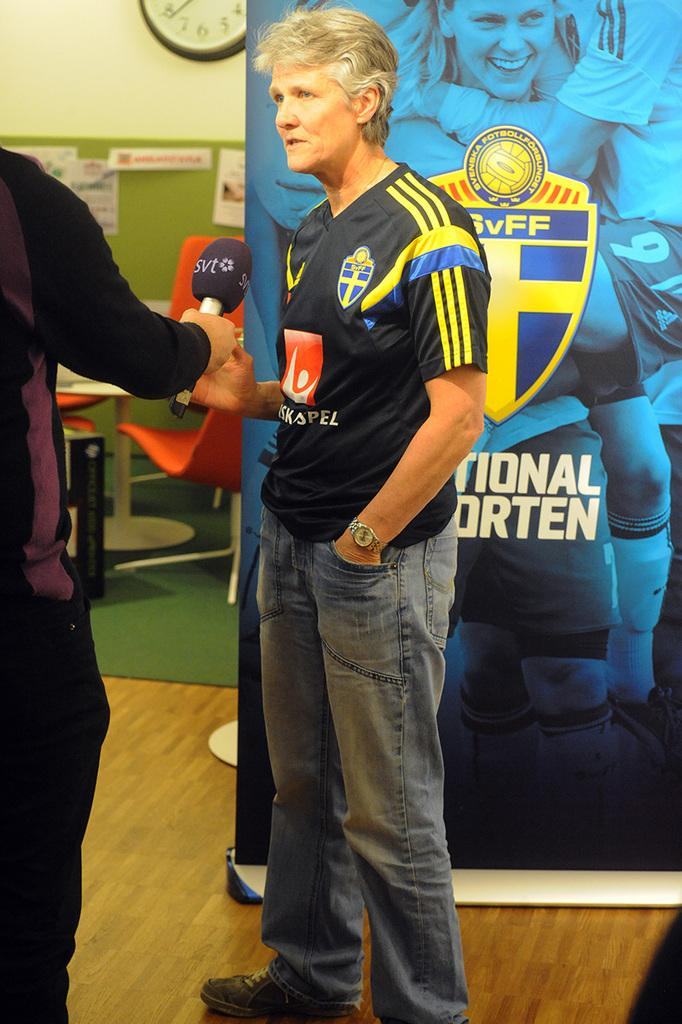What are the two men in the image doing? The two men in the image are standing and talking. What is at the bottom of the image? There is a floor at the bottom of the image. What can be seen in the background of the image? There is a floor and a wall visible in the background of the image. What is fixed on the wall in the background? A clock is fixed on the wall. What type of sleet is falling in the image? There is no mention of sleet or any weather condition in the image. 